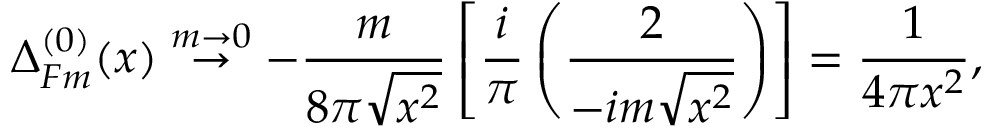Convert formula to latex. <formula><loc_0><loc_0><loc_500><loc_500>\Delta _ { F m } ^ { ( 0 ) } ( x ) \stackrel { m \rightarrow 0 } { \rightarrow } - \frac { m } { 8 \pi \sqrt { x ^ { 2 } } } \left [ \frac { i } { \pi } \left ( \frac { 2 } { - i m \sqrt { x ^ { 2 } } } \right ) \right ] = \frac { 1 } { 4 \pi x ^ { 2 } } ,</formula> 